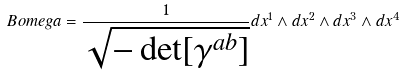<formula> <loc_0><loc_0><loc_500><loc_500>\ B o m e g a = \frac { 1 } { \sqrt { - \det [ \gamma ^ { a b } ] } } d x ^ { 1 } \wedge d x ^ { 2 } \wedge d x ^ { 3 } \wedge d x ^ { 4 }</formula> 